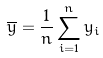Convert formula to latex. <formula><loc_0><loc_0><loc_500><loc_500>\overline { y } = \frac { 1 } { n } \sum _ { i = 1 } ^ { n } y _ { i }</formula> 